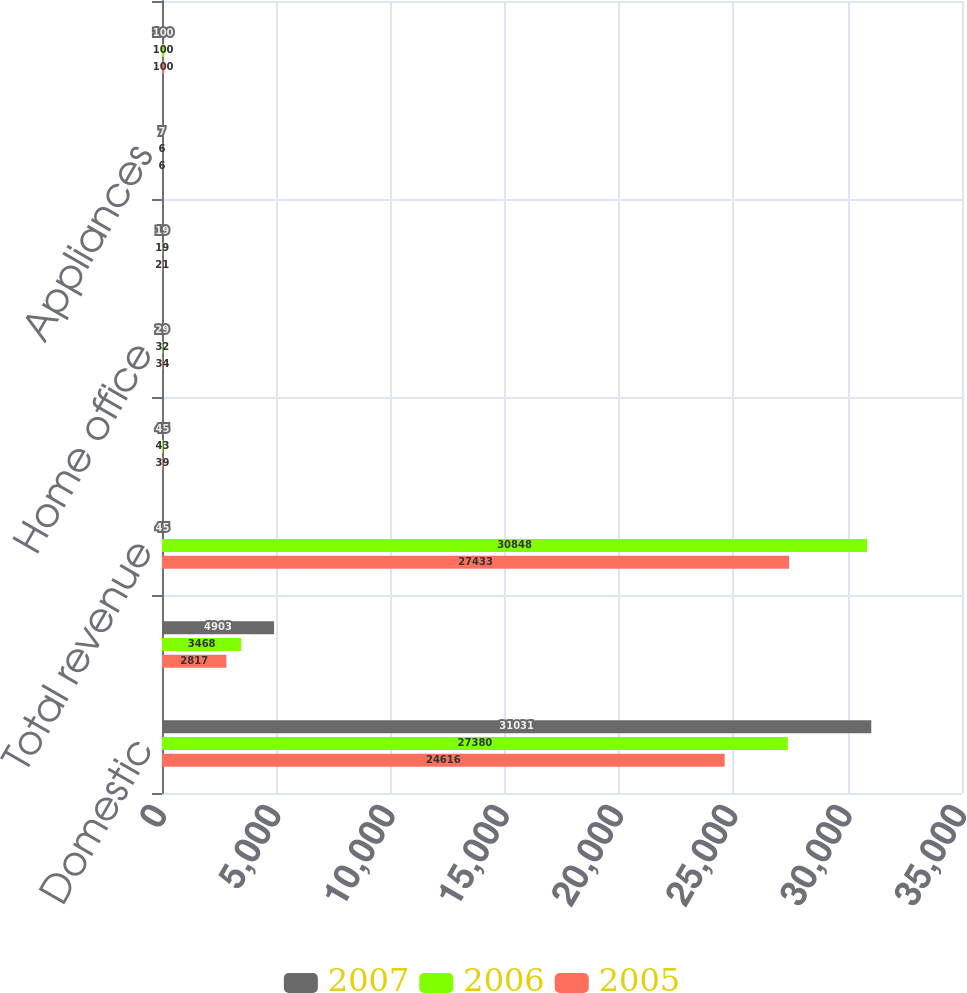Convert chart. <chart><loc_0><loc_0><loc_500><loc_500><stacked_bar_chart><ecel><fcel>Domestic<fcel>International<fcel>Total revenue<fcel>Consumer electronics<fcel>Home office<fcel>Entertainment software<fcel>Appliances<fcel>Total<nl><fcel>2007<fcel>31031<fcel>4903<fcel>45<fcel>45<fcel>29<fcel>19<fcel>7<fcel>100<nl><fcel>2006<fcel>27380<fcel>3468<fcel>30848<fcel>43<fcel>32<fcel>19<fcel>6<fcel>100<nl><fcel>2005<fcel>24616<fcel>2817<fcel>27433<fcel>39<fcel>34<fcel>21<fcel>6<fcel>100<nl></chart> 